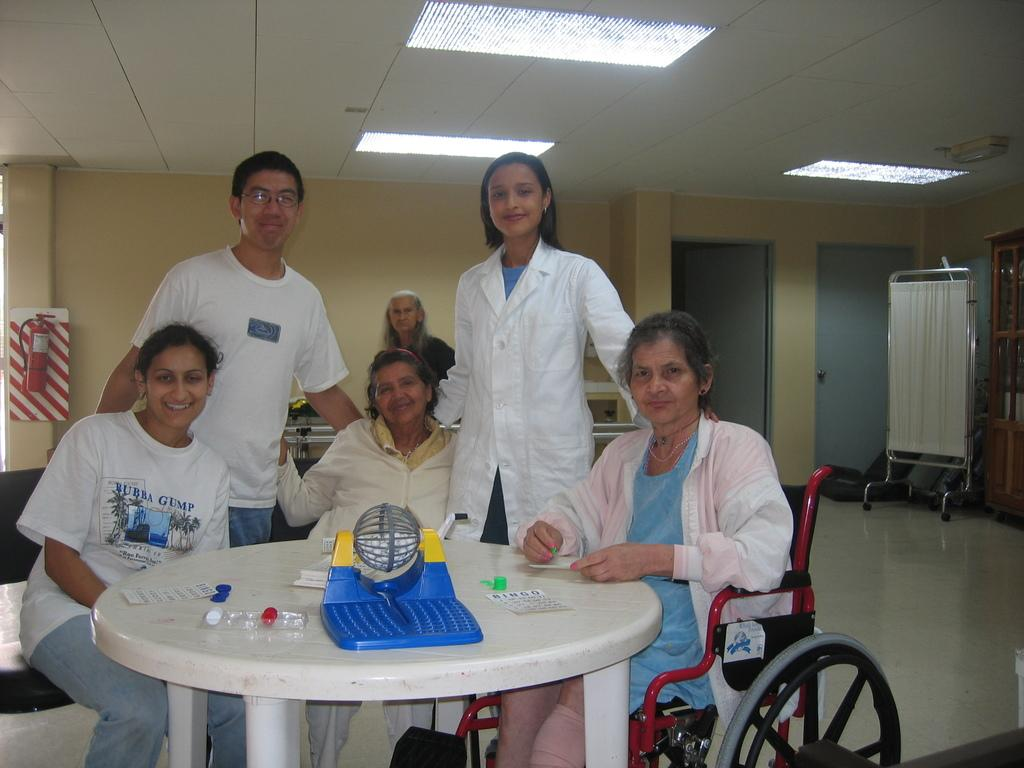What color is the wall that is visible in the image? There is a yellow color wall in the image. What object can be seen in the image besides the wall? There is a cloth in the image. What are the people in the image doing? The people in the image are sitting and standing. What is located in the front of the image? There is a table in the front of the image. What is placed on the table in the image? There is a tablet sheet on the table. Is there a fight happening in the image? There is no indication of a fight in the image; people are sitting and standing. Is the image set in a cellar? There is no information about the location of the image, but it does not appear to be set in a cellar. 